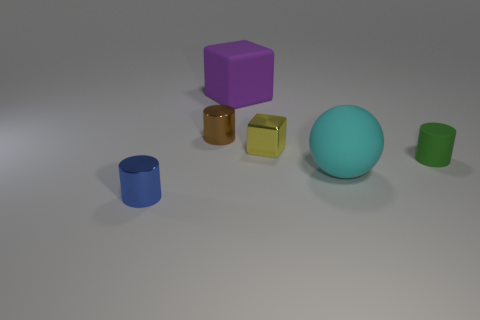Are there any tiny green cylinders on the left side of the tiny green matte object?
Give a very brief answer. No. Is the large object that is in front of the tiny green matte thing made of the same material as the big thing behind the sphere?
Give a very brief answer. Yes. Is the number of small green cylinders behind the cyan matte sphere less than the number of tiny rubber objects?
Your response must be concise. No. What is the color of the tiny cylinder that is on the right side of the tiny yellow metal block?
Keep it short and to the point. Green. What material is the cylinder that is to the left of the shiny cylinder that is behind the tiny green matte cylinder?
Ensure brevity in your answer.  Metal. Is there a rubber cylinder that has the same size as the yellow metallic object?
Your answer should be very brief. Yes. How many objects are big rubber objects to the right of the rubber block or objects that are on the left side of the rubber cylinder?
Offer a very short reply. 5. Do the brown cylinder left of the cyan matte sphere and the cylinder that is to the right of the large purple cube have the same size?
Provide a short and direct response. Yes. There is a block that is to the right of the big matte cube; are there any tiny cylinders in front of it?
Keep it short and to the point. Yes. How many rubber things are right of the cyan sphere?
Your answer should be compact. 1. 